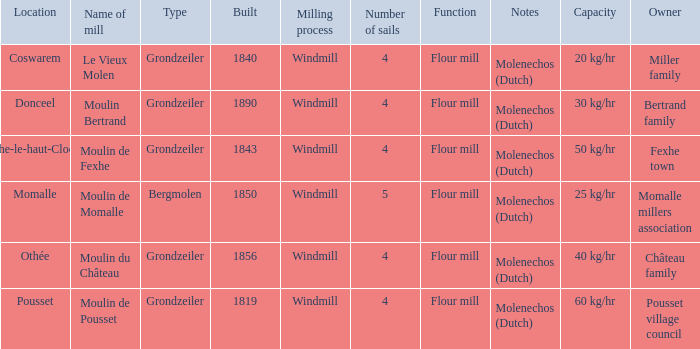What is the Location of the Moulin Bertrand Mill? Donceel. 